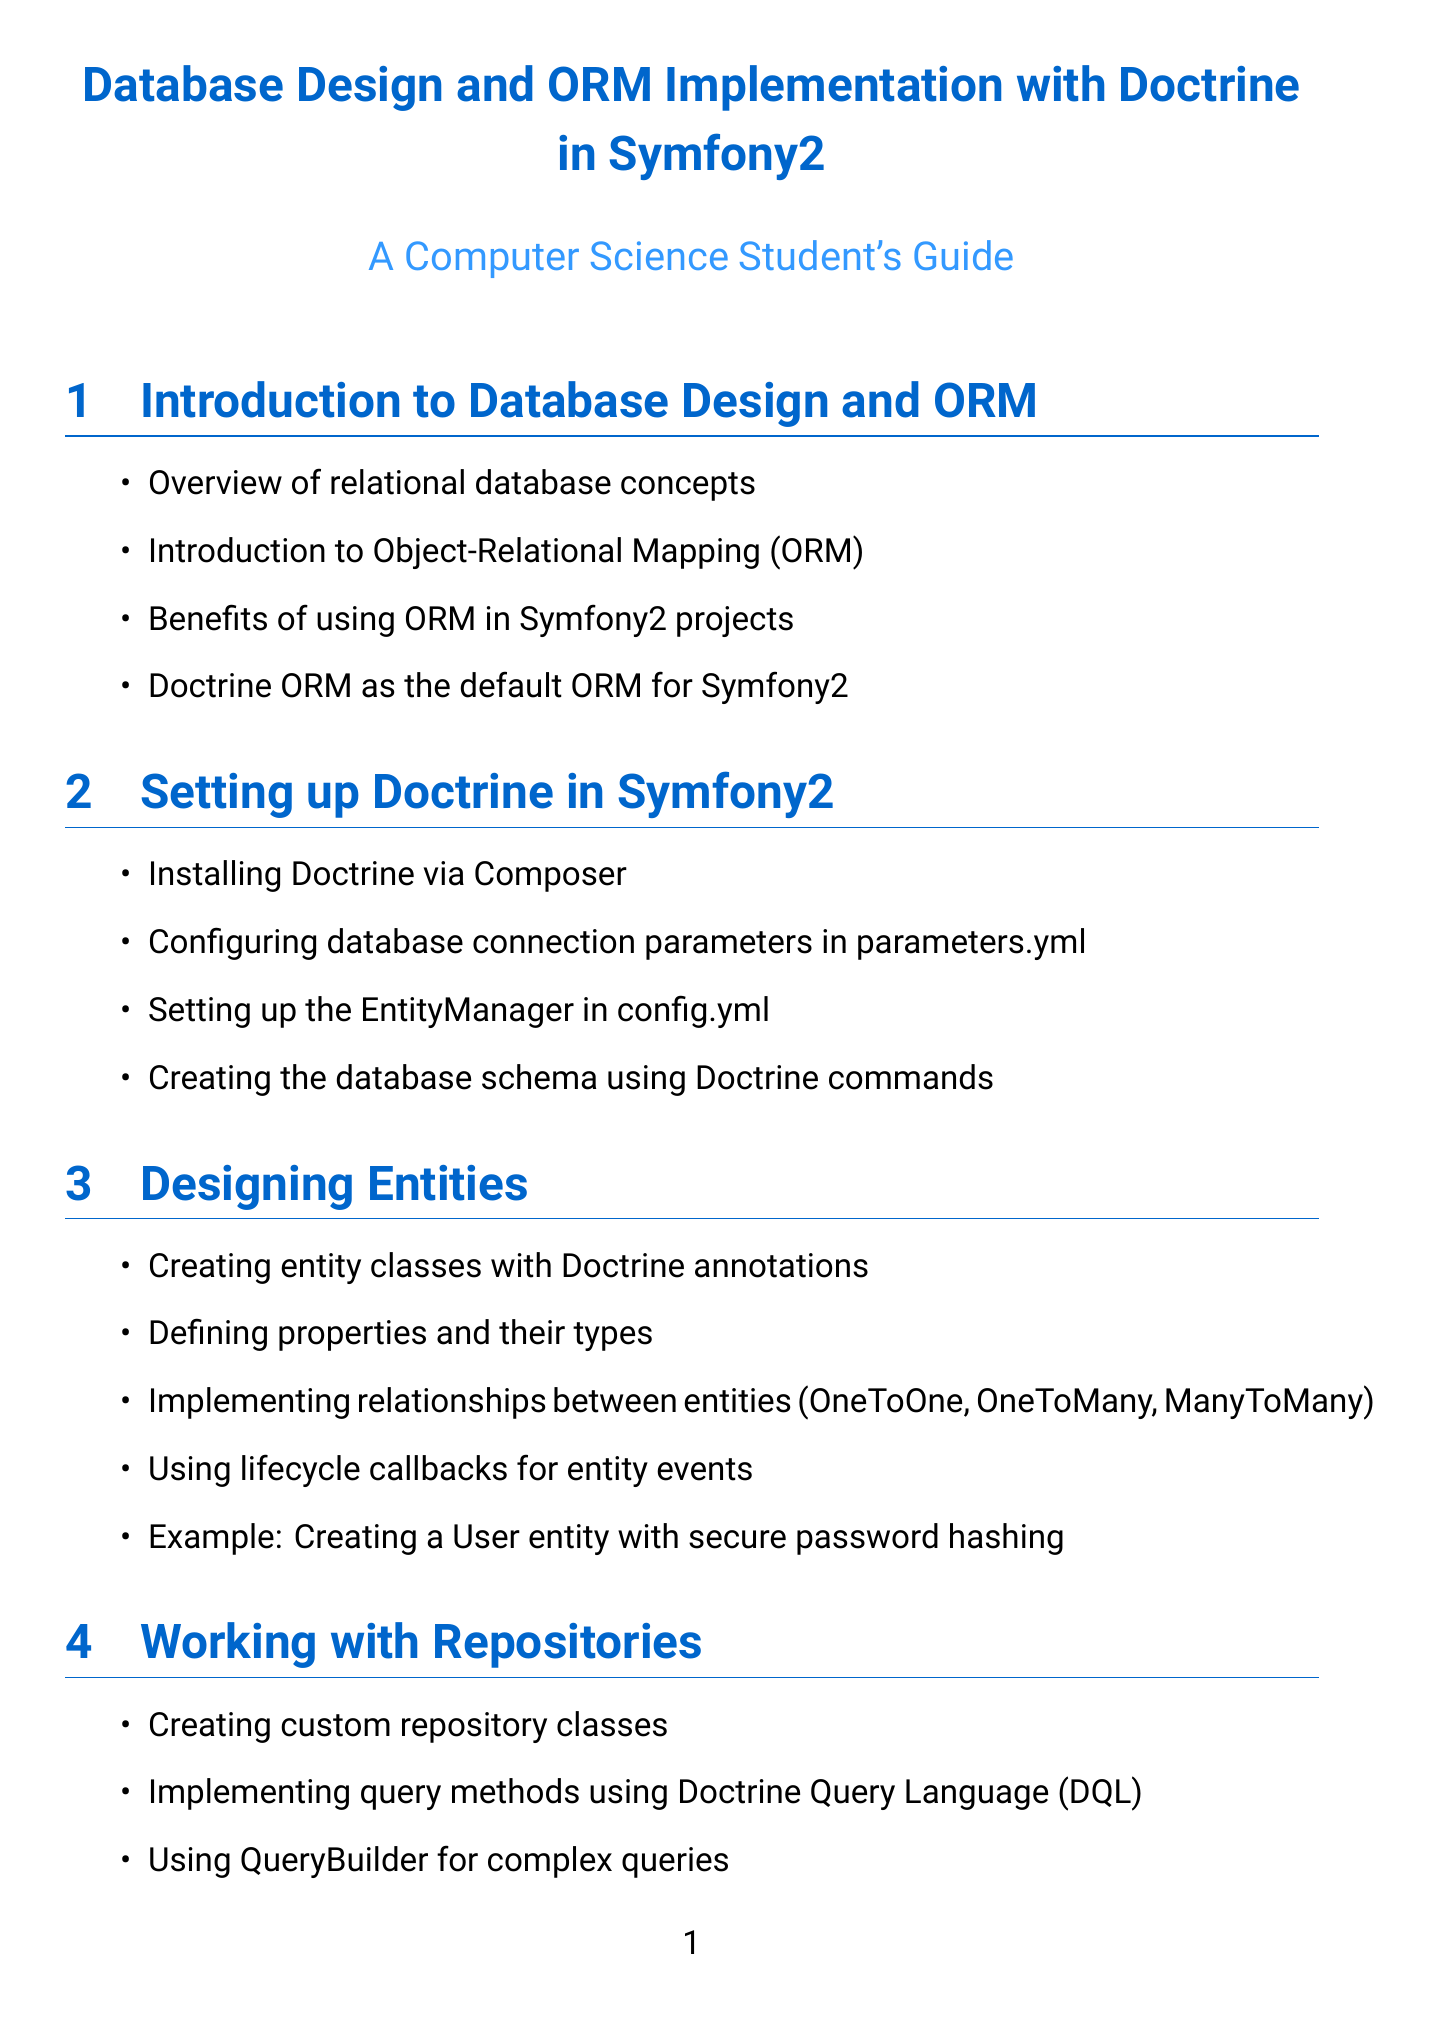What is the default ORM for Symfony2? The section titled "Introduction to Database Design and ORM" states that Doctrine ORM is the default ORM for Symfony2.
Answer: Doctrine ORM How are database connection parameters configured? In the section "Setting up Doctrine in Symfony2," it mentions configuring database connection parameters in parameters.yml.
Answer: parameters.yml What is implemented using Symfony's PasswordHasherInterface? In the section "Security Considerations," it states that secure password hashing is implemented using Symfony's PasswordHasherInterface.
Answer: secure password hashing Which design pattern is encouraged for creating custom queries? The section "Working with Repositories" discusses implementing query methods using Doctrine Query Language (DQL), indicating the design pattern for this purpose.
Answer: Doctrine Query Language What type of caching does Doctrine provide for performance optimization? The section "Performance Optimization" refers to using Doctrine's second-level cache for improved performance.
Answer: second-level cache What does the User entity's eraseCredentials method do? The example in the "Secure User Entity" section indicates that eraseCredentials clears any temporary, sensitive data on the user.
Answer: clear sensitive data Which feature allows managing schema changes? The "Database Migrations" section introduces the Doctrine Migrations bundle as a tool for managing schema changes across different environments.
Answer: Doctrine Migrations bundle What is the purpose of lifecycle callbacks in entity design? In the section "Designing Entities," the purpose of lifecycle callbacks is related to handling entity events during the entity's lifecycle.
Answer: handling entity events What are the benefits of following best practices in Symfony2? The section "Best Practices and Common Pitfalls" emphasizes maintainable code through following best practices of Symfony2 and Doctrine.
Answer: maintainable code 